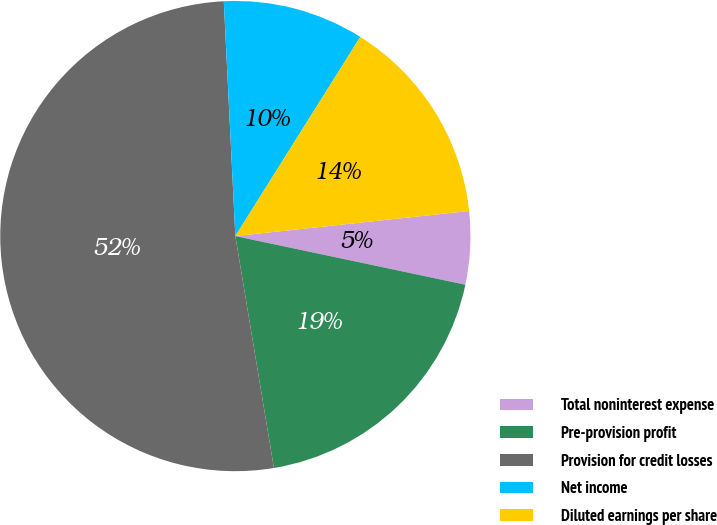Convert chart. <chart><loc_0><loc_0><loc_500><loc_500><pie_chart><fcel>Total noninterest expense<fcel>Pre-provision profit<fcel>Provision for credit losses<fcel>Net income<fcel>Diluted earnings per share<nl><fcel>5.02%<fcel>19.06%<fcel>51.84%<fcel>9.7%<fcel>14.38%<nl></chart> 